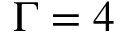Convert formula to latex. <formula><loc_0><loc_0><loc_500><loc_500>\Gamma = 4</formula> 